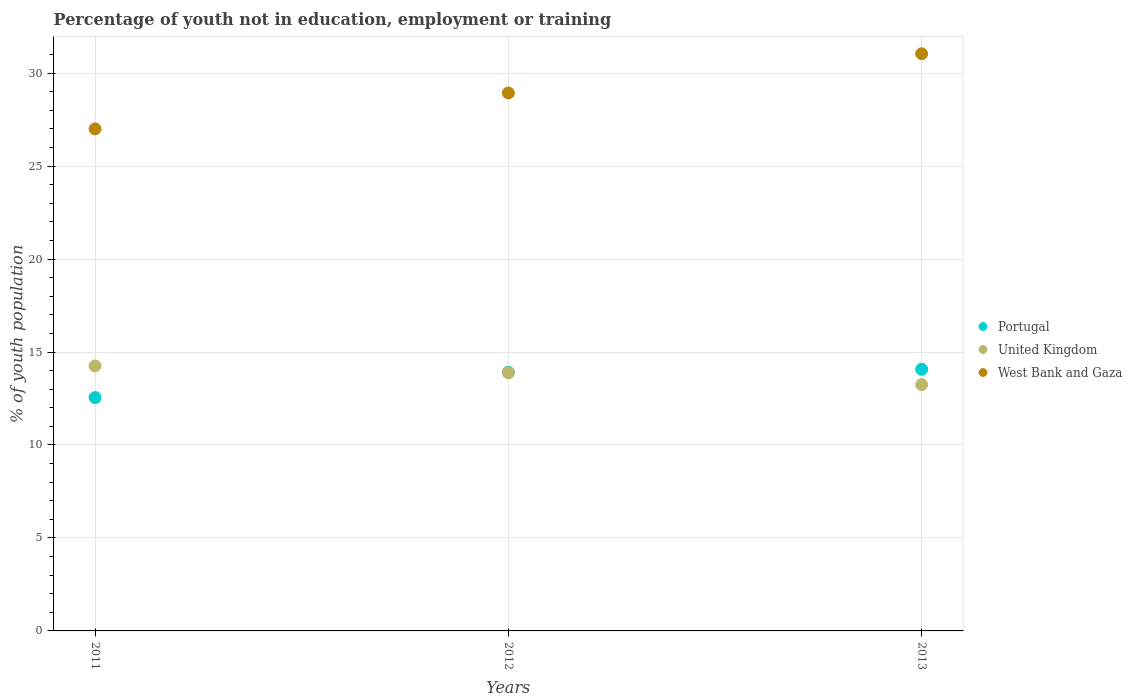How many different coloured dotlines are there?
Your answer should be compact. 3. What is the percentage of unemployed youth population in in West Bank and Gaza in 2013?
Your answer should be compact. 31.04. Across all years, what is the maximum percentage of unemployed youth population in in United Kingdom?
Ensure brevity in your answer.  14.25. Across all years, what is the minimum percentage of unemployed youth population in in United Kingdom?
Offer a terse response. 13.25. In which year was the percentage of unemployed youth population in in Portugal minimum?
Ensure brevity in your answer.  2011. What is the total percentage of unemployed youth population in in Portugal in the graph?
Offer a terse response. 40.53. What is the difference between the percentage of unemployed youth population in in Portugal in 2011 and that in 2013?
Make the answer very short. -1.52. What is the difference between the percentage of unemployed youth population in in West Bank and Gaza in 2011 and the percentage of unemployed youth population in in United Kingdom in 2013?
Provide a succinct answer. 13.75. What is the average percentage of unemployed youth population in in United Kingdom per year?
Your answer should be compact. 13.79. In the year 2011, what is the difference between the percentage of unemployed youth population in in United Kingdom and percentage of unemployed youth population in in West Bank and Gaza?
Your answer should be compact. -12.75. What is the ratio of the percentage of unemployed youth population in in United Kingdom in 2011 to that in 2013?
Offer a terse response. 1.08. What is the difference between the highest and the second highest percentage of unemployed youth population in in United Kingdom?
Your response must be concise. 0.37. What is the difference between the highest and the lowest percentage of unemployed youth population in in United Kingdom?
Keep it short and to the point. 1. In how many years, is the percentage of unemployed youth population in in Portugal greater than the average percentage of unemployed youth population in in Portugal taken over all years?
Your response must be concise. 2. Is the sum of the percentage of unemployed youth population in in Portugal in 2011 and 2012 greater than the maximum percentage of unemployed youth population in in West Bank and Gaza across all years?
Keep it short and to the point. No. Is the percentage of unemployed youth population in in Portugal strictly greater than the percentage of unemployed youth population in in United Kingdom over the years?
Provide a succinct answer. No. Is the percentage of unemployed youth population in in United Kingdom strictly less than the percentage of unemployed youth population in in West Bank and Gaza over the years?
Give a very brief answer. Yes. How many years are there in the graph?
Offer a very short reply. 3. What is the difference between two consecutive major ticks on the Y-axis?
Provide a short and direct response. 5. Are the values on the major ticks of Y-axis written in scientific E-notation?
Offer a very short reply. No. Does the graph contain any zero values?
Offer a terse response. No. Does the graph contain grids?
Your answer should be compact. Yes. Where does the legend appear in the graph?
Offer a terse response. Center right. What is the title of the graph?
Offer a terse response. Percentage of youth not in education, employment or training. Does "Gambia, The" appear as one of the legend labels in the graph?
Your response must be concise. No. What is the label or title of the X-axis?
Provide a short and direct response. Years. What is the label or title of the Y-axis?
Give a very brief answer. % of youth population. What is the % of youth population in Portugal in 2011?
Your answer should be very brief. 12.55. What is the % of youth population in United Kingdom in 2011?
Offer a very short reply. 14.25. What is the % of youth population in Portugal in 2012?
Give a very brief answer. 13.91. What is the % of youth population in United Kingdom in 2012?
Provide a succinct answer. 13.88. What is the % of youth population of West Bank and Gaza in 2012?
Your answer should be very brief. 28.93. What is the % of youth population of Portugal in 2013?
Provide a succinct answer. 14.07. What is the % of youth population of United Kingdom in 2013?
Provide a short and direct response. 13.25. What is the % of youth population in West Bank and Gaza in 2013?
Keep it short and to the point. 31.04. Across all years, what is the maximum % of youth population of Portugal?
Offer a terse response. 14.07. Across all years, what is the maximum % of youth population in United Kingdom?
Ensure brevity in your answer.  14.25. Across all years, what is the maximum % of youth population of West Bank and Gaza?
Offer a very short reply. 31.04. Across all years, what is the minimum % of youth population in Portugal?
Your response must be concise. 12.55. Across all years, what is the minimum % of youth population of United Kingdom?
Your answer should be very brief. 13.25. What is the total % of youth population in Portugal in the graph?
Your answer should be very brief. 40.53. What is the total % of youth population of United Kingdom in the graph?
Your response must be concise. 41.38. What is the total % of youth population of West Bank and Gaza in the graph?
Give a very brief answer. 86.97. What is the difference between the % of youth population of Portugal in 2011 and that in 2012?
Keep it short and to the point. -1.36. What is the difference between the % of youth population of United Kingdom in 2011 and that in 2012?
Offer a very short reply. 0.37. What is the difference between the % of youth population in West Bank and Gaza in 2011 and that in 2012?
Offer a terse response. -1.93. What is the difference between the % of youth population in Portugal in 2011 and that in 2013?
Your response must be concise. -1.52. What is the difference between the % of youth population of United Kingdom in 2011 and that in 2013?
Offer a very short reply. 1. What is the difference between the % of youth population in West Bank and Gaza in 2011 and that in 2013?
Ensure brevity in your answer.  -4.04. What is the difference between the % of youth population in Portugal in 2012 and that in 2013?
Offer a terse response. -0.16. What is the difference between the % of youth population of United Kingdom in 2012 and that in 2013?
Ensure brevity in your answer.  0.63. What is the difference between the % of youth population of West Bank and Gaza in 2012 and that in 2013?
Give a very brief answer. -2.11. What is the difference between the % of youth population of Portugal in 2011 and the % of youth population of United Kingdom in 2012?
Keep it short and to the point. -1.33. What is the difference between the % of youth population of Portugal in 2011 and the % of youth population of West Bank and Gaza in 2012?
Make the answer very short. -16.38. What is the difference between the % of youth population of United Kingdom in 2011 and the % of youth population of West Bank and Gaza in 2012?
Your answer should be compact. -14.68. What is the difference between the % of youth population in Portugal in 2011 and the % of youth population in United Kingdom in 2013?
Provide a short and direct response. -0.7. What is the difference between the % of youth population of Portugal in 2011 and the % of youth population of West Bank and Gaza in 2013?
Offer a terse response. -18.49. What is the difference between the % of youth population of United Kingdom in 2011 and the % of youth population of West Bank and Gaza in 2013?
Make the answer very short. -16.79. What is the difference between the % of youth population of Portugal in 2012 and the % of youth population of United Kingdom in 2013?
Ensure brevity in your answer.  0.66. What is the difference between the % of youth population of Portugal in 2012 and the % of youth population of West Bank and Gaza in 2013?
Give a very brief answer. -17.13. What is the difference between the % of youth population of United Kingdom in 2012 and the % of youth population of West Bank and Gaza in 2013?
Provide a short and direct response. -17.16. What is the average % of youth population in Portugal per year?
Ensure brevity in your answer.  13.51. What is the average % of youth population in United Kingdom per year?
Your answer should be compact. 13.79. What is the average % of youth population of West Bank and Gaza per year?
Your answer should be very brief. 28.99. In the year 2011, what is the difference between the % of youth population in Portugal and % of youth population in United Kingdom?
Provide a short and direct response. -1.7. In the year 2011, what is the difference between the % of youth population of Portugal and % of youth population of West Bank and Gaza?
Provide a succinct answer. -14.45. In the year 2011, what is the difference between the % of youth population of United Kingdom and % of youth population of West Bank and Gaza?
Keep it short and to the point. -12.75. In the year 2012, what is the difference between the % of youth population of Portugal and % of youth population of United Kingdom?
Provide a succinct answer. 0.03. In the year 2012, what is the difference between the % of youth population in Portugal and % of youth population in West Bank and Gaza?
Offer a terse response. -15.02. In the year 2012, what is the difference between the % of youth population in United Kingdom and % of youth population in West Bank and Gaza?
Provide a short and direct response. -15.05. In the year 2013, what is the difference between the % of youth population of Portugal and % of youth population of United Kingdom?
Your answer should be compact. 0.82. In the year 2013, what is the difference between the % of youth population in Portugal and % of youth population in West Bank and Gaza?
Your answer should be compact. -16.97. In the year 2013, what is the difference between the % of youth population in United Kingdom and % of youth population in West Bank and Gaza?
Your answer should be very brief. -17.79. What is the ratio of the % of youth population in Portugal in 2011 to that in 2012?
Ensure brevity in your answer.  0.9. What is the ratio of the % of youth population of United Kingdom in 2011 to that in 2012?
Ensure brevity in your answer.  1.03. What is the ratio of the % of youth population in Portugal in 2011 to that in 2013?
Ensure brevity in your answer.  0.89. What is the ratio of the % of youth population of United Kingdom in 2011 to that in 2013?
Offer a terse response. 1.08. What is the ratio of the % of youth population of West Bank and Gaza in 2011 to that in 2013?
Your answer should be compact. 0.87. What is the ratio of the % of youth population in United Kingdom in 2012 to that in 2013?
Provide a succinct answer. 1.05. What is the ratio of the % of youth population in West Bank and Gaza in 2012 to that in 2013?
Provide a succinct answer. 0.93. What is the difference between the highest and the second highest % of youth population of Portugal?
Provide a short and direct response. 0.16. What is the difference between the highest and the second highest % of youth population of United Kingdom?
Your answer should be compact. 0.37. What is the difference between the highest and the second highest % of youth population in West Bank and Gaza?
Your response must be concise. 2.11. What is the difference between the highest and the lowest % of youth population of Portugal?
Ensure brevity in your answer.  1.52. What is the difference between the highest and the lowest % of youth population of West Bank and Gaza?
Ensure brevity in your answer.  4.04. 